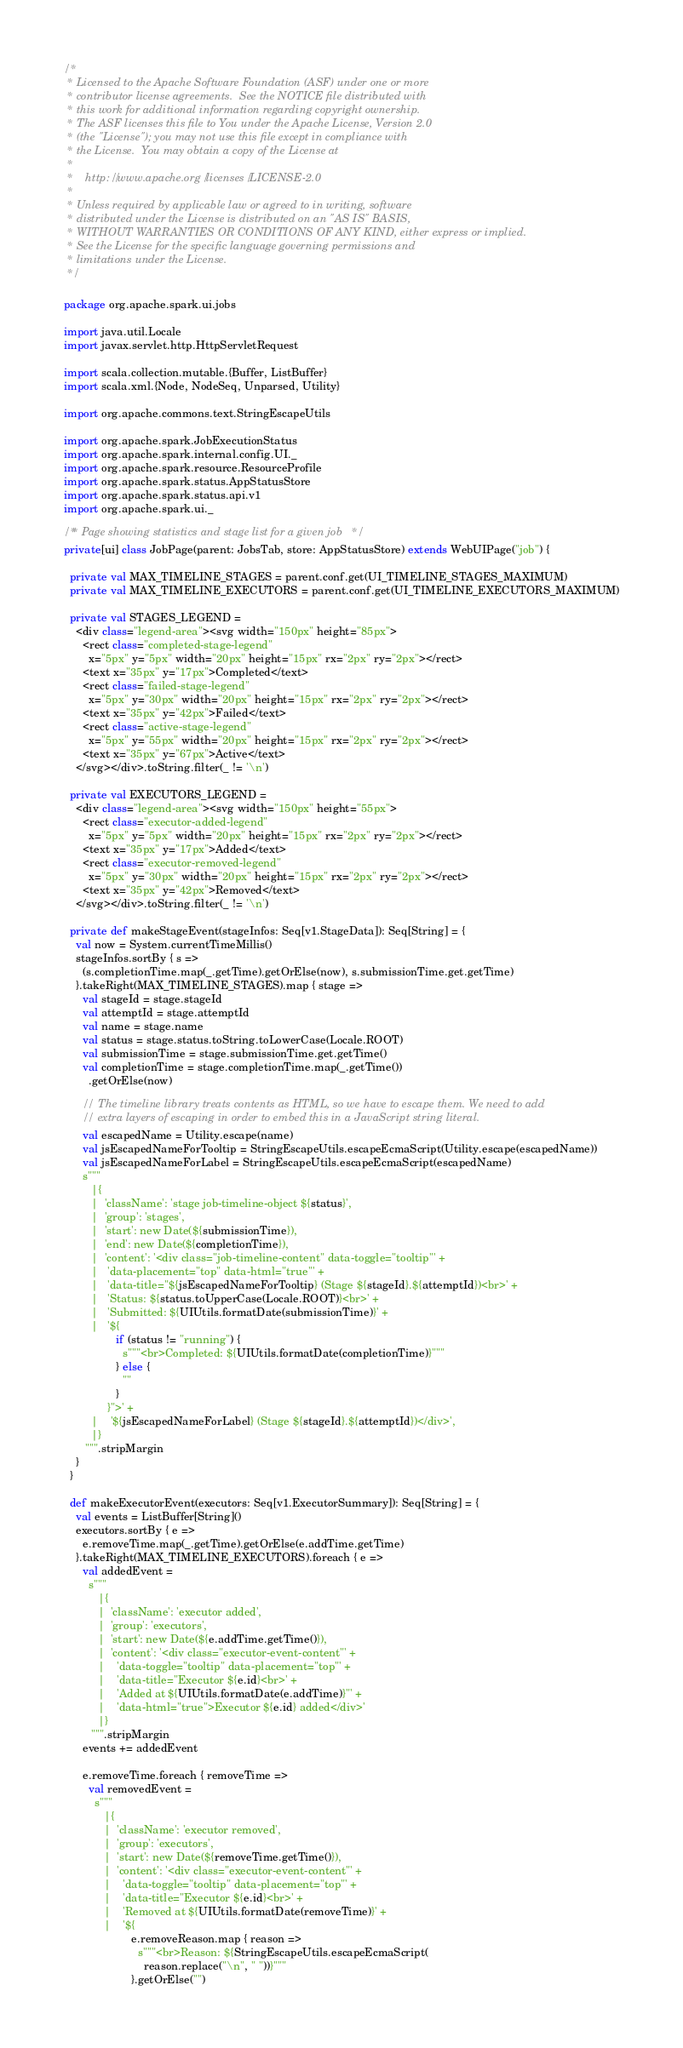<code> <loc_0><loc_0><loc_500><loc_500><_Scala_>/*
 * Licensed to the Apache Software Foundation (ASF) under one or more
 * contributor license agreements.  See the NOTICE file distributed with
 * this work for additional information regarding copyright ownership.
 * The ASF licenses this file to You under the Apache License, Version 2.0
 * (the "License"); you may not use this file except in compliance with
 * the License.  You may obtain a copy of the License at
 *
 *    http://www.apache.org/licenses/LICENSE-2.0
 *
 * Unless required by applicable law or agreed to in writing, software
 * distributed under the License is distributed on an "AS IS" BASIS,
 * WITHOUT WARRANTIES OR CONDITIONS OF ANY KIND, either express or implied.
 * See the License for the specific language governing permissions and
 * limitations under the License.
 */

package org.apache.spark.ui.jobs

import java.util.Locale
import javax.servlet.http.HttpServletRequest

import scala.collection.mutable.{Buffer, ListBuffer}
import scala.xml.{Node, NodeSeq, Unparsed, Utility}

import org.apache.commons.text.StringEscapeUtils

import org.apache.spark.JobExecutionStatus
import org.apache.spark.internal.config.UI._
import org.apache.spark.resource.ResourceProfile
import org.apache.spark.status.AppStatusStore
import org.apache.spark.status.api.v1
import org.apache.spark.ui._

/** Page showing statistics and stage list for a given job */
private[ui] class JobPage(parent: JobsTab, store: AppStatusStore) extends WebUIPage("job") {

  private val MAX_TIMELINE_STAGES = parent.conf.get(UI_TIMELINE_STAGES_MAXIMUM)
  private val MAX_TIMELINE_EXECUTORS = parent.conf.get(UI_TIMELINE_EXECUTORS_MAXIMUM)

  private val STAGES_LEGEND =
    <div class="legend-area"><svg width="150px" height="85px">
      <rect class="completed-stage-legend"
        x="5px" y="5px" width="20px" height="15px" rx="2px" ry="2px"></rect>
      <text x="35px" y="17px">Completed</text>
      <rect class="failed-stage-legend"
        x="5px" y="30px" width="20px" height="15px" rx="2px" ry="2px"></rect>
      <text x="35px" y="42px">Failed</text>
      <rect class="active-stage-legend"
        x="5px" y="55px" width="20px" height="15px" rx="2px" ry="2px"></rect>
      <text x="35px" y="67px">Active</text>
    </svg></div>.toString.filter(_ != '\n')

  private val EXECUTORS_LEGEND =
    <div class="legend-area"><svg width="150px" height="55px">
      <rect class="executor-added-legend"
        x="5px" y="5px" width="20px" height="15px" rx="2px" ry="2px"></rect>
      <text x="35px" y="17px">Added</text>
      <rect class="executor-removed-legend"
        x="5px" y="30px" width="20px" height="15px" rx="2px" ry="2px"></rect>
      <text x="35px" y="42px">Removed</text>
    </svg></div>.toString.filter(_ != '\n')

  private def makeStageEvent(stageInfos: Seq[v1.StageData]): Seq[String] = {
    val now = System.currentTimeMillis()
    stageInfos.sortBy { s =>
      (s.completionTime.map(_.getTime).getOrElse(now), s.submissionTime.get.getTime)
    }.takeRight(MAX_TIMELINE_STAGES).map { stage =>
      val stageId = stage.stageId
      val attemptId = stage.attemptId
      val name = stage.name
      val status = stage.status.toString.toLowerCase(Locale.ROOT)
      val submissionTime = stage.submissionTime.get.getTime()
      val completionTime = stage.completionTime.map(_.getTime())
        .getOrElse(now)

      // The timeline library treats contents as HTML, so we have to escape them. We need to add
      // extra layers of escaping in order to embed this in a JavaScript string literal.
      val escapedName = Utility.escape(name)
      val jsEscapedNameForTooltip = StringEscapeUtils.escapeEcmaScript(Utility.escape(escapedName))
      val jsEscapedNameForLabel = StringEscapeUtils.escapeEcmaScript(escapedName)
      s"""
         |{
         |  'className': 'stage job-timeline-object ${status}',
         |  'group': 'stages',
         |  'start': new Date(${submissionTime}),
         |  'end': new Date(${completionTime}),
         |  'content': '<div class="job-timeline-content" data-toggle="tooltip"' +
         |   'data-placement="top" data-html="true"' +
         |   'data-title="${jsEscapedNameForTooltip} (Stage ${stageId}.${attemptId})<br>' +
         |   'Status: ${status.toUpperCase(Locale.ROOT)}<br>' +
         |   'Submitted: ${UIUtils.formatDate(submissionTime)}' +
         |   '${
                 if (status != "running") {
                   s"""<br>Completed: ${UIUtils.formatDate(completionTime)}"""
                 } else {
                   ""
                 }
              }">' +
         |    '${jsEscapedNameForLabel} (Stage ${stageId}.${attemptId})</div>',
         |}
       """.stripMargin
    }
  }

  def makeExecutorEvent(executors: Seq[v1.ExecutorSummary]): Seq[String] = {
    val events = ListBuffer[String]()
    executors.sortBy { e =>
      e.removeTime.map(_.getTime).getOrElse(e.addTime.getTime)
    }.takeRight(MAX_TIMELINE_EXECUTORS).foreach { e =>
      val addedEvent =
        s"""
           |{
           |  'className': 'executor added',
           |  'group': 'executors',
           |  'start': new Date(${e.addTime.getTime()}),
           |  'content': '<div class="executor-event-content"' +
           |    'data-toggle="tooltip" data-placement="top"' +
           |    'data-title="Executor ${e.id}<br>' +
           |    'Added at ${UIUtils.formatDate(e.addTime)}"' +
           |    'data-html="true">Executor ${e.id} added</div>'
           |}
         """.stripMargin
      events += addedEvent

      e.removeTime.foreach { removeTime =>
        val removedEvent =
          s"""
             |{
             |  'className': 'executor removed',
             |  'group': 'executors',
             |  'start': new Date(${removeTime.getTime()}),
             |  'content': '<div class="executor-event-content"' +
             |    'data-toggle="tooltip" data-placement="top"' +
             |    'data-title="Executor ${e.id}<br>' +
             |    'Removed at ${UIUtils.formatDate(removeTime)}' +
             |    '${
                      e.removeReason.map { reason =>
                        s"""<br>Reason: ${StringEscapeUtils.escapeEcmaScript(
                          reason.replace("\n", " "))}"""
                      }.getOrElse("")</code> 